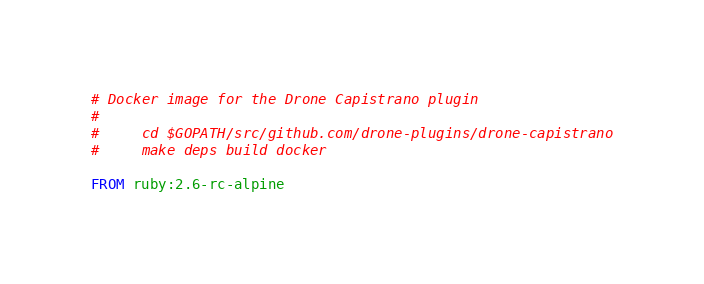Convert code to text. <code><loc_0><loc_0><loc_500><loc_500><_Dockerfile_># Docker image for the Drone Capistrano plugin
#
#     cd $GOPATH/src/github.com/drone-plugins/drone-capistrano
#     make deps build docker

FROM ruby:2.6-rc-alpine
</code> 